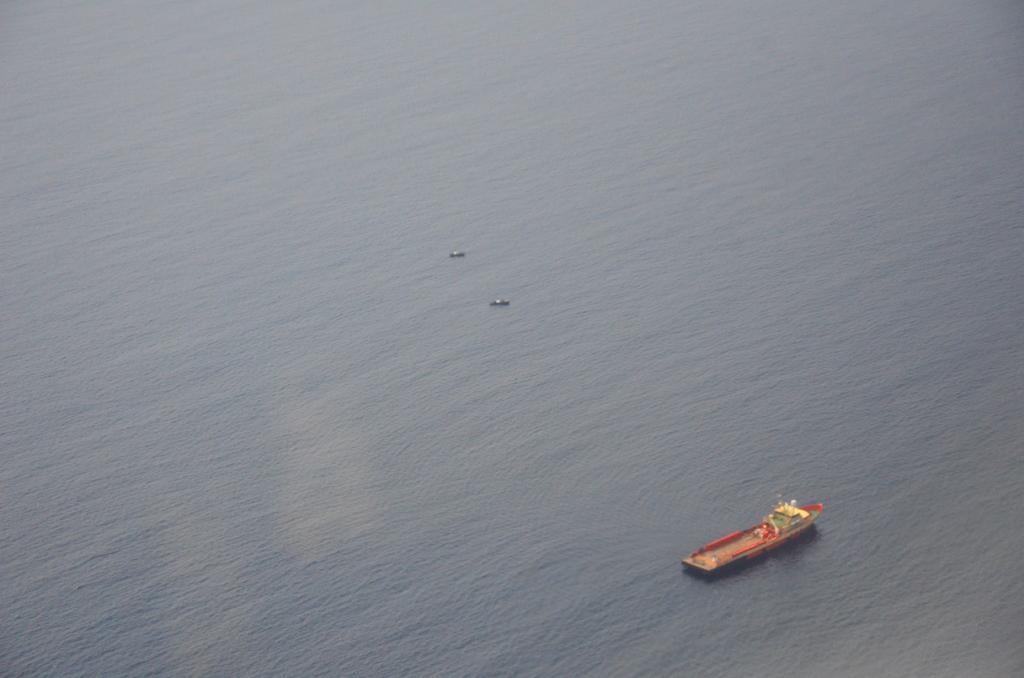In one or two sentences, can you explain what this image depicts? In this picture there is a boat at the bottom side of the image and there is water around the area of the image. 